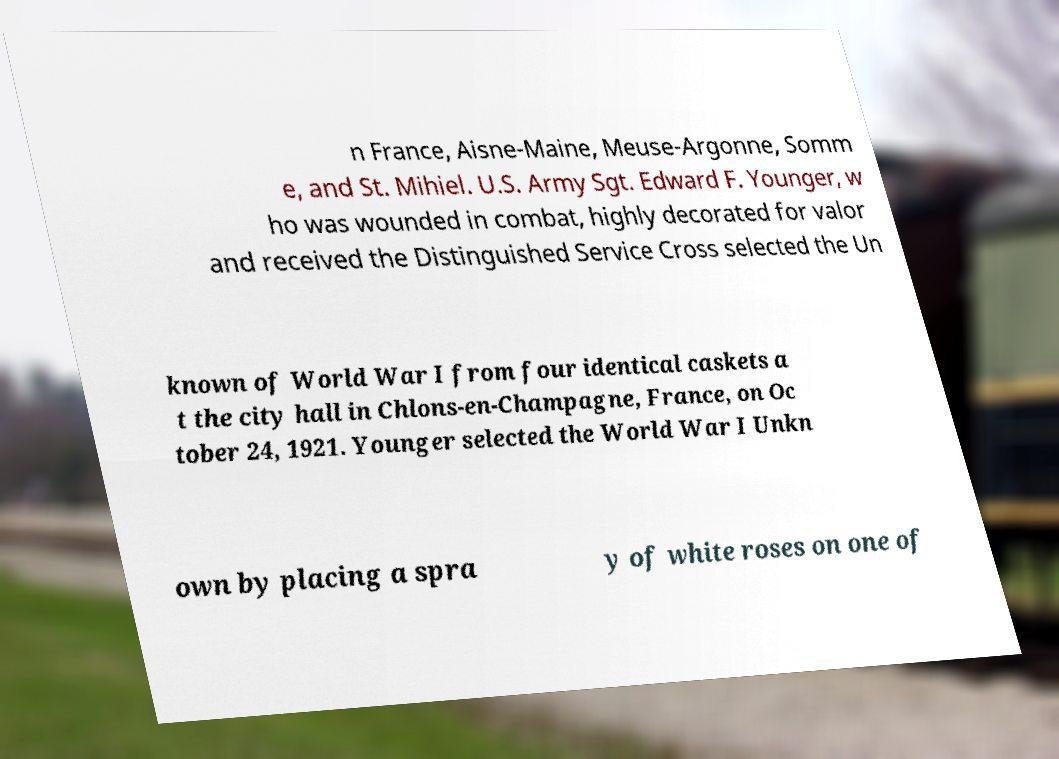I need the written content from this picture converted into text. Can you do that? n France, Aisne-Maine, Meuse-Argonne, Somm e, and St. Mihiel. U.S. Army Sgt. Edward F. Younger, w ho was wounded in combat, highly decorated for valor and received the Distinguished Service Cross selected the Un known of World War I from four identical caskets a t the city hall in Chlons-en-Champagne, France, on Oc tober 24, 1921. Younger selected the World War I Unkn own by placing a spra y of white roses on one of 